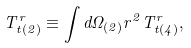<formula> <loc_0><loc_0><loc_500><loc_500>T ^ { r } _ { t ( 2 ) } \equiv \int d \Omega _ { ( 2 ) } r ^ { 2 } T ^ { r } _ { t ( 4 ) } ,</formula> 